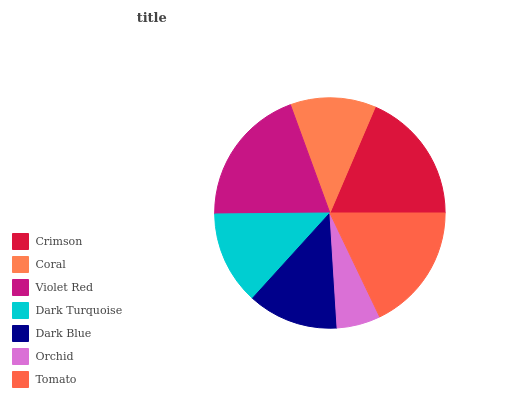Is Orchid the minimum?
Answer yes or no. Yes. Is Violet Red the maximum?
Answer yes or no. Yes. Is Coral the minimum?
Answer yes or no. No. Is Coral the maximum?
Answer yes or no. No. Is Crimson greater than Coral?
Answer yes or no. Yes. Is Coral less than Crimson?
Answer yes or no. Yes. Is Coral greater than Crimson?
Answer yes or no. No. Is Crimson less than Coral?
Answer yes or no. No. Is Dark Turquoise the high median?
Answer yes or no. Yes. Is Dark Turquoise the low median?
Answer yes or no. Yes. Is Tomato the high median?
Answer yes or no. No. Is Dark Blue the low median?
Answer yes or no. No. 